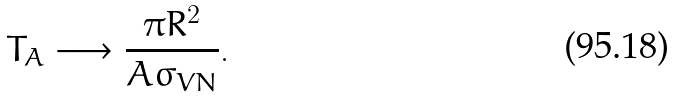Convert formula to latex. <formula><loc_0><loc_0><loc_500><loc_500>T _ { A } \longrightarrow \frac { \pi R ^ { 2 } } { A \sigma _ { V N } } .</formula> 